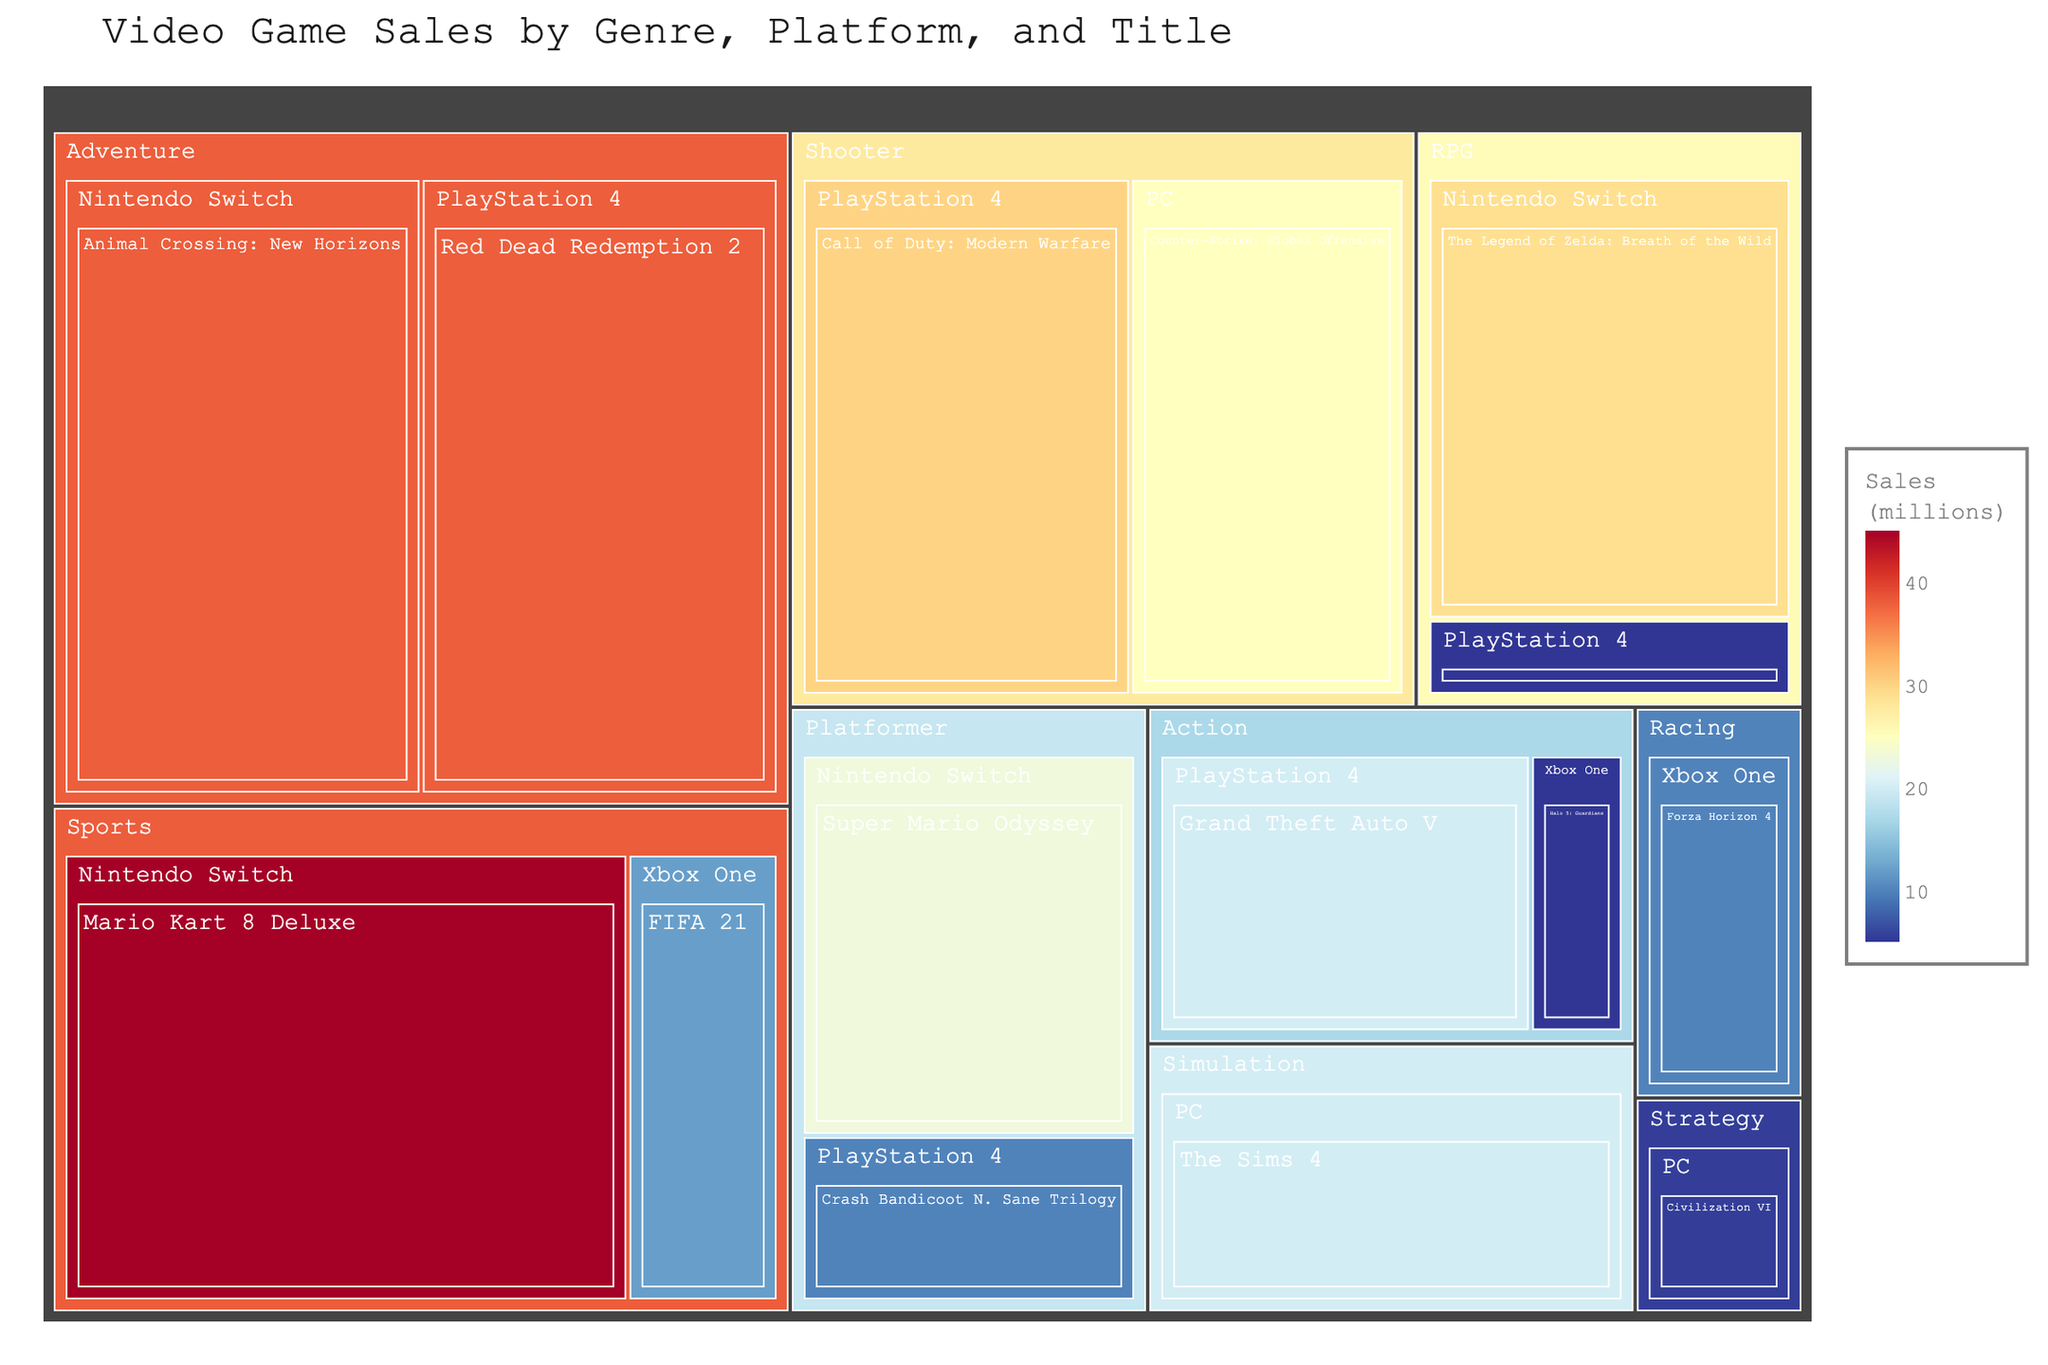How many top-selling titles are there in the Sports genre? To find the answer, look for the Sports genre in the Treemap and count the number of titles within it.
Answer: 2 Which title has the highest sales within the Adventure genre? Identify the Adventure genre and observe the titles within it. Compare the sales figures of these titles to determine the highest one.
Answer: Animal Crossing: New Horizons What is the total sales figure for titles on the PlayStation 4 platform? Locate all the titles under the PlayStation 4 platform in the Treemap. Sum the sales figures: Grand Theft Auto V (20) + Call of Duty: Modern Warfare (30) + Red Dead Redemption 2 (38) + Crash Bandicoot N. Sane Trilogy (10) + Final Fantasy VII Remake (5). The sum is 103 million.
Answer: 103 million How do the sales of "The Legend of Zelda: Breath of the Wild" compare to those of "Super Mario Odyssey"? Identify the sales figures of both titles: The Legend of Zelda: Breath of the Wild (29) and Super Mario Odyssey (23). Compare these figures. 29 is greater than 23.
Answer: The Legend of Zelda: Breath of the Wild has higher sales What is the average sales figure for titles in the RPG genre? Identify the RPG titles and their sales figures: The Legend of Zelda: Breath of the Wild (29) and Final Fantasy VII Remake (5). The sum is 34, and there are 2 titles, so the average is 34/2 = 17 million.
Answer: 17 million Which title has the lowest sales in the entire Treemap? Scan through the sales figures across all genres and platforms. The title with the lowest sales is identified as 5.5 million for Civilization VI.
Answer: Civilization VI Among the listed platforms, which one has the highest cumulative sales for all the titles it hosts? Sum the sales figures for each platform:
PlayStation 4: 20 + 30 + 38 + 10 + 5 = 103
Nintendo Switch: 29 + 23 + 45 + 38 = 135
Xbox One: 12 + 10 + 5 = 27
PC: 5.5 + 20 + 25 = 50.5
The Nintendo Switch has the highest cumulative sales.
Answer: Nintendo Switch Which genre has the most number of top-selling titles? Count the titles within each genre in the Treemap. Adventure has 2 titles, same as Action. More investigation shows Adventure has some of the highest-selling games overall.
Answer: Adventure What is the difference in sales between "Red Dead Redemption 2" and "Grand Theft Auto V"? Identify the sales figures of both titles: Red Dead Redemption 2 (38) and Grand Theft Auto V (20). Calculate the difference: 38 - 20 = 18.
Answer: 18 million Which genre's titles are primarily dominated by PC platform in terms of sales? Identify the genres with titles on the PC platform and compare their sales. Simulation (The Sims 4, 20) and Shooter (Counter-Strike: Global Offensive, 25) are two main ones. Shooter has higher sales.
Answer: Shooter 